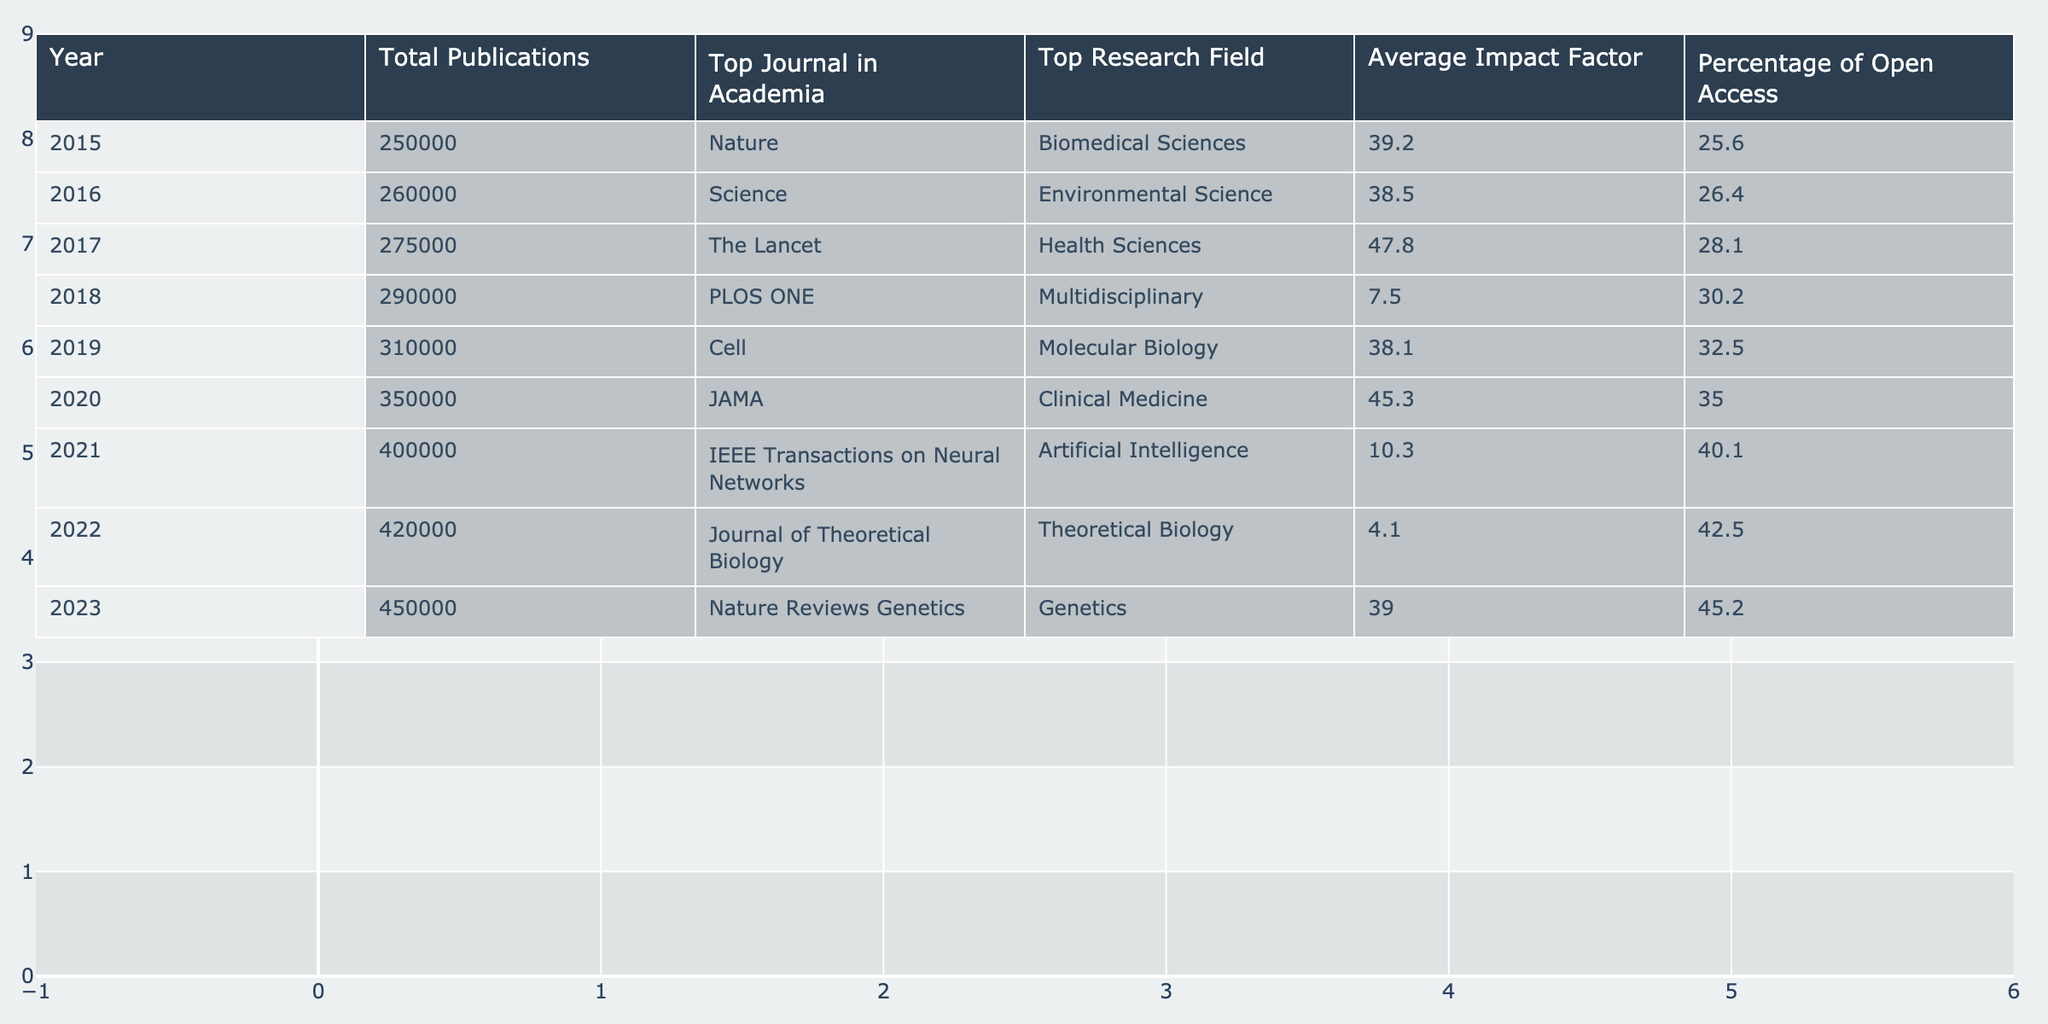What was the total number of publications in 2020? According to the table, the total number of publications in 2020 is directly listed as 350,000.
Answer: 350000 Which research field had the highest average impact factor in 2017? The table shows that in 2017, the highest average impact factor was 47.8, which is associated with the Health Sciences field.
Answer: Health Sciences What is the percentage increase in total publications from 2015 to 2023? The total publications in 2015 were 250,000, and in 2023 they rose to 450,000. The increase is 450,000 - 250,000 = 200,000. To find the percentage increase, divide the increase by the original value: (200,000 / 250,000) * 100 = 80%.
Answer: 80% In which year did the top journal in academia switch from a journal with an impact factor higher than 30 to one with an impact factor lower than 30? The top journal in academia with an impact factor higher than 30 is "The Lancet" in 2017 (impact factor 47.8). The next year, 2018, "PLOS ONE" has an impact factor of 7.5, which is less than 30. Therefore, the switch occurred in 2018.
Answer: 2018 How many years did it take for the percentage of open access publications to increase from below 30% to above 40%? The table states that in 2019, the percentage of open access was 32.5%, and it reached 40.1% in 2021. This means it took from 2019 to 2021, which is 2 years.
Answer: 2 years Is the average impact factor for the top journal in 2022 higher or lower than that in 2021? In 2021, the average impact factor of the top journal was 10.3, while in 2022 it was 4.1. Since 4.1 is less than 10.3, we conclude that it is lower.
Answer: Lower What was the trend of total publications from 2015 to 2023? By observing the values in the "Total Publications" column for each year, we see a consistent upward trend: from 250,000 in 2015 to 450,000 in 2023, with each following year showing an increase, resulting in a positive growth trajectory over the period.
Answer: Upward trend What is the average impact factor over the years from 2015 to 2023? To find the average impact factor, sum the impact factors for each year (39.2 + 38.5 + 47.8 + 7.5 + 38.1 + 45.3 + 10.3 + 4.1 + 39.0) = 269.8, and then divide by the number of years (9), resulting in an average impact factor of approximately 29.98.
Answer: Approximately 29.98 In which year was the top research field "Molecular Biology" mentioned? The table indicates that "Molecular Biology" is listed as the top research field for the year 2019 specifically.
Answer: 2019 What was the highest percentage of open access publications recorded in the table? The table shows that the highest recorded percentage of open access publications was 45.2% in the year 2023.
Answer: 45.2% 